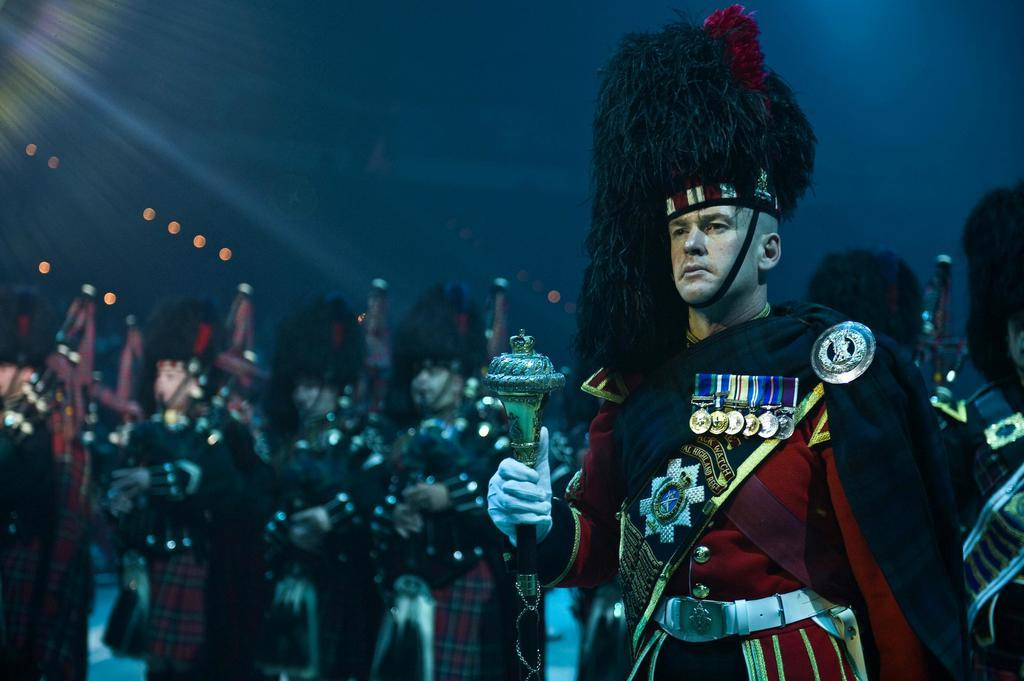What is the position of the person in the image? There is a person standing on the right side of the image. What is the person holding in the image? The person is holding an object. Can you describe the background of the image? There are other persons standing in the background of the image. What type of desk can be seen in the image? There is no desk present in the image. Can you describe the branch that the person is holding in the image? The person is not holding a branch in the image; they are holding an object. 